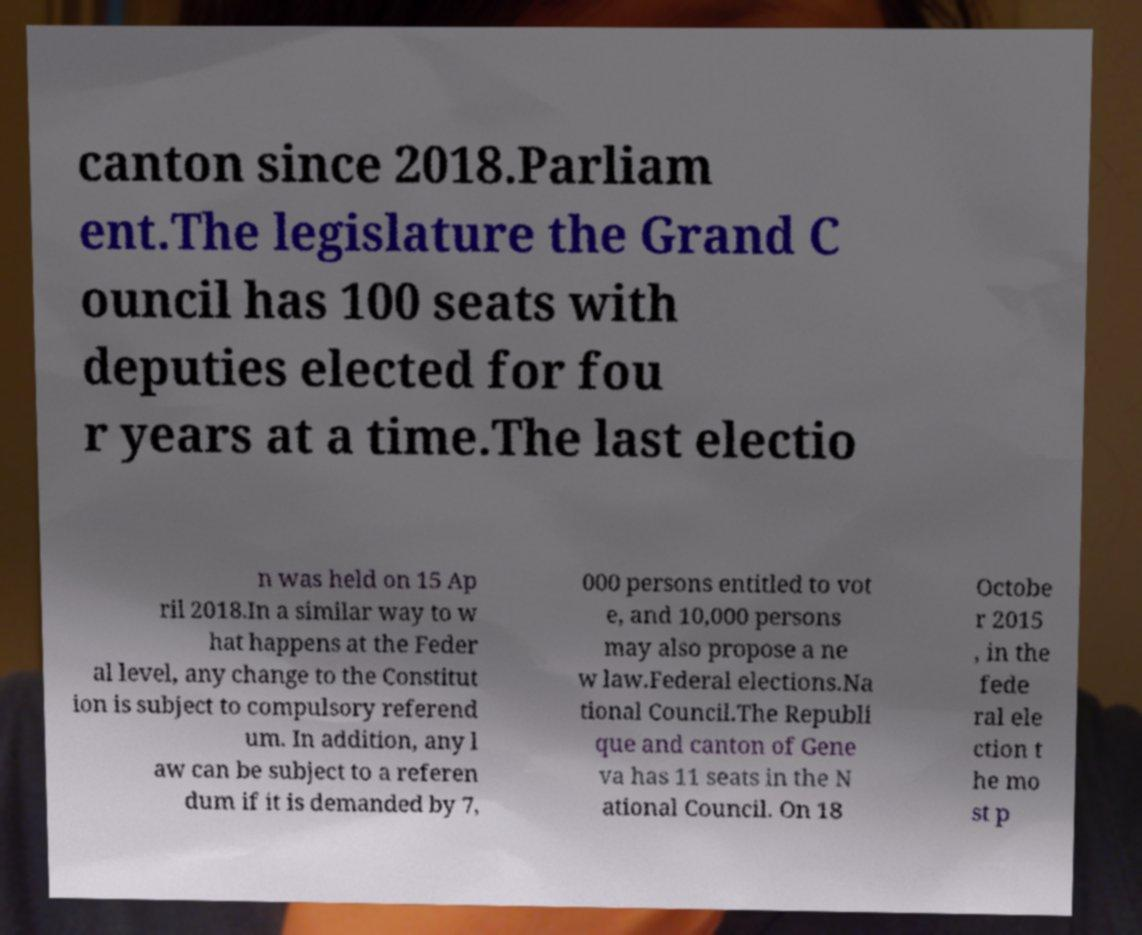Can you accurately transcribe the text from the provided image for me? canton since 2018.Parliam ent.The legislature the Grand C ouncil has 100 seats with deputies elected for fou r years at a time.The last electio n was held on 15 Ap ril 2018.In a similar way to w hat happens at the Feder al level, any change to the Constitut ion is subject to compulsory referend um. In addition, any l aw can be subject to a referen dum if it is demanded by 7, 000 persons entitled to vot e, and 10,000 persons may also propose a ne w law.Federal elections.Na tional Council.The Republi que and canton of Gene va has 11 seats in the N ational Council. On 18 Octobe r 2015 , in the fede ral ele ction t he mo st p 